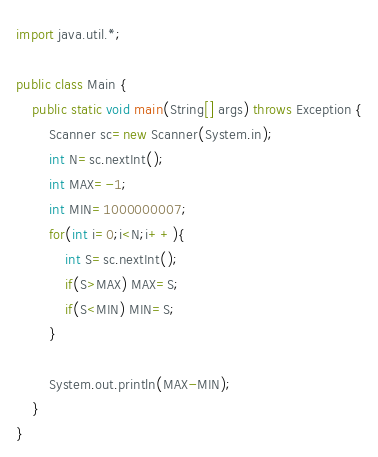<code> <loc_0><loc_0><loc_500><loc_500><_Java_>import java.util.*;

public class Main {
    public static void main(String[] args) throws Exception {
        Scanner sc=new Scanner(System.in);
        int N=sc.nextInt();
        int MAX=-1;
        int MIN=1000000007;
        for(int i=0;i<N;i++){
            int S=sc.nextInt();
            if(S>MAX) MAX=S;
            if(S<MIN) MIN=S;
        }
        
        System.out.println(MAX-MIN);
    }
}
</code> 